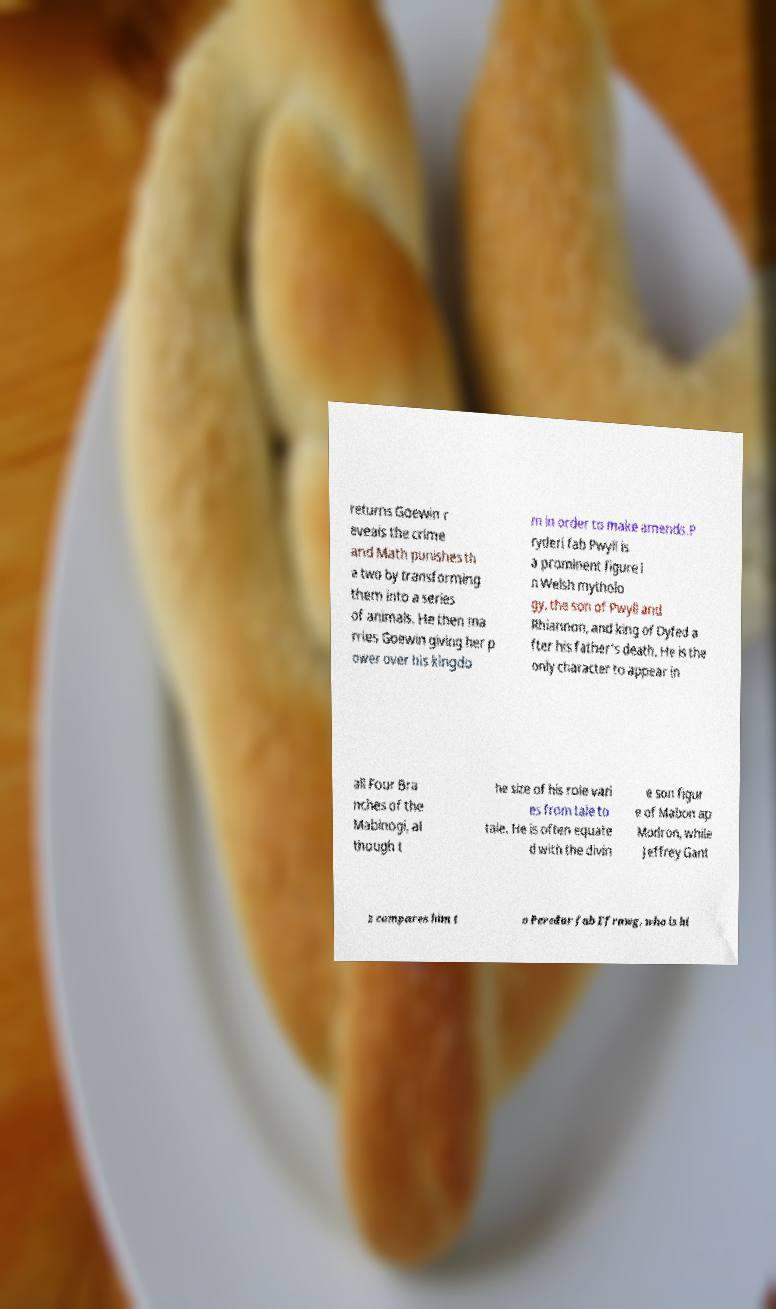Please identify and transcribe the text found in this image. returns Goewin r eveals the crime and Math punishes th e two by transforming them into a series of animals. He then ma rries Goewin giving her p ower over his kingdo m in order to make amends.P ryderi fab Pwyll is a prominent figure i n Welsh mytholo gy, the son of Pwyll and Rhiannon, and king of Dyfed a fter his father's death. He is the only character to appear in all Four Bra nches of the Mabinogi, al though t he size of his role vari es from tale to tale. He is often equate d with the divin e son figur e of Mabon ap Modron, while Jeffrey Gant z compares him t o Peredur fab Efrawg, who is hi 